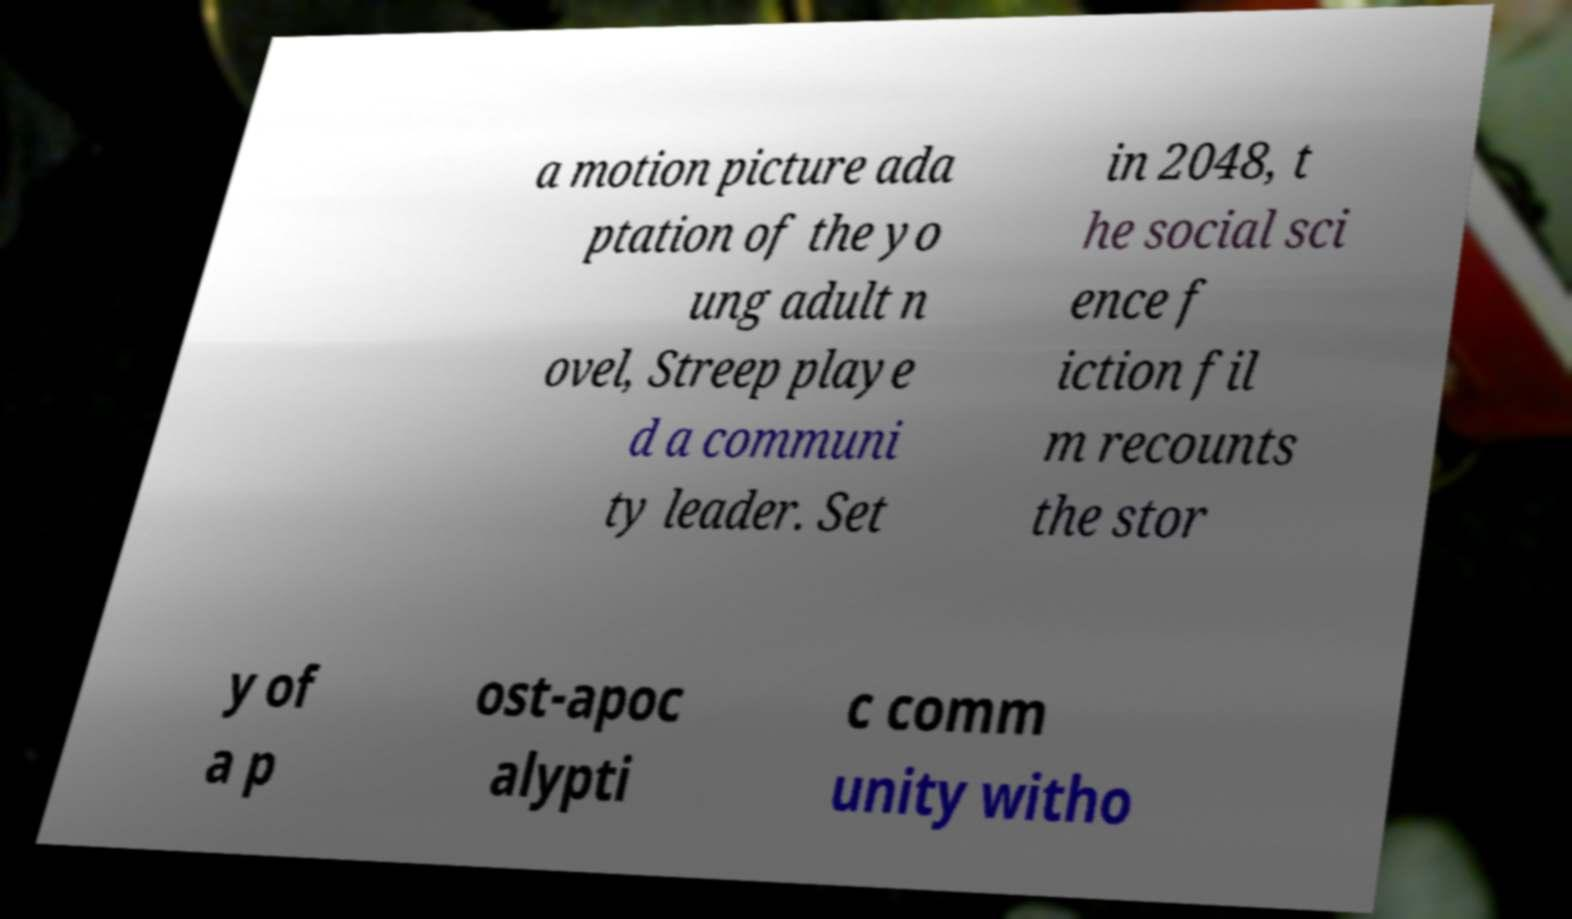For documentation purposes, I need the text within this image transcribed. Could you provide that? a motion picture ada ptation of the yo ung adult n ovel, Streep playe d a communi ty leader. Set in 2048, t he social sci ence f iction fil m recounts the stor y of a p ost-apoc alypti c comm unity witho 